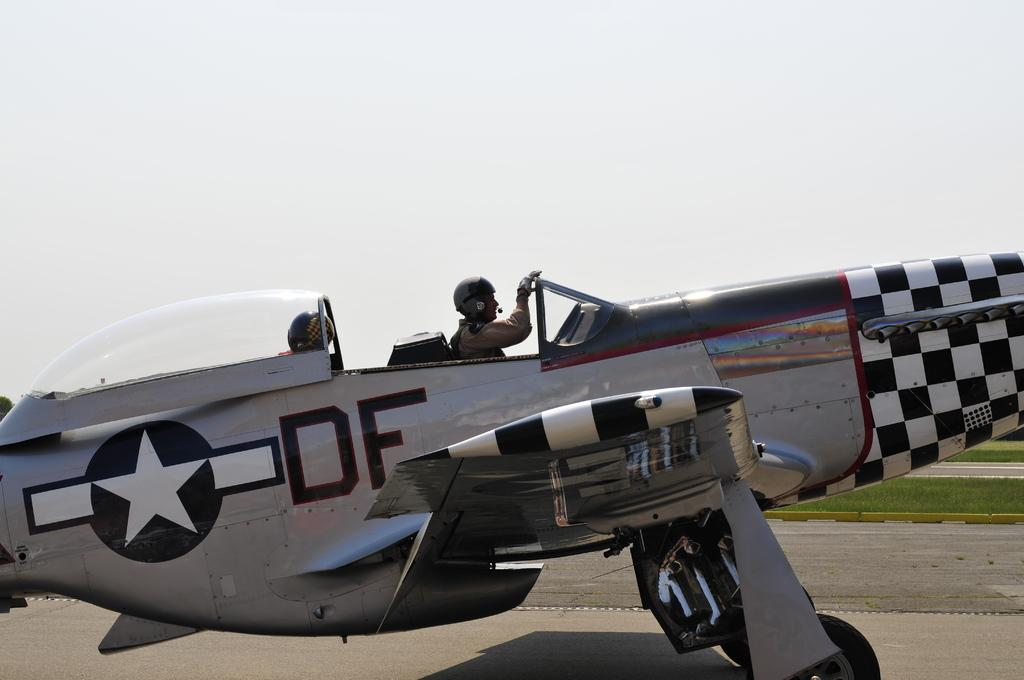<image>
Summarize the visual content of the image. An old fighter jet has a star and the letters DF on the side 